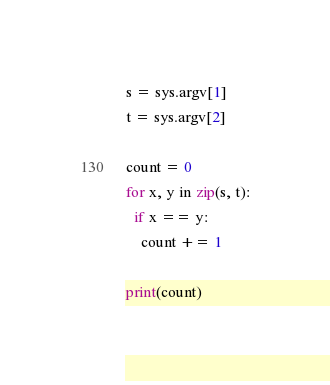Convert code to text. <code><loc_0><loc_0><loc_500><loc_500><_Python_>s = sys.argv[1]
t = sys.argv[2]

count = 0
for x, y in zip(s, t):
  if x == y:
    count += 1
    
print(count)</code> 